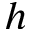<formula> <loc_0><loc_0><loc_500><loc_500>h</formula> 